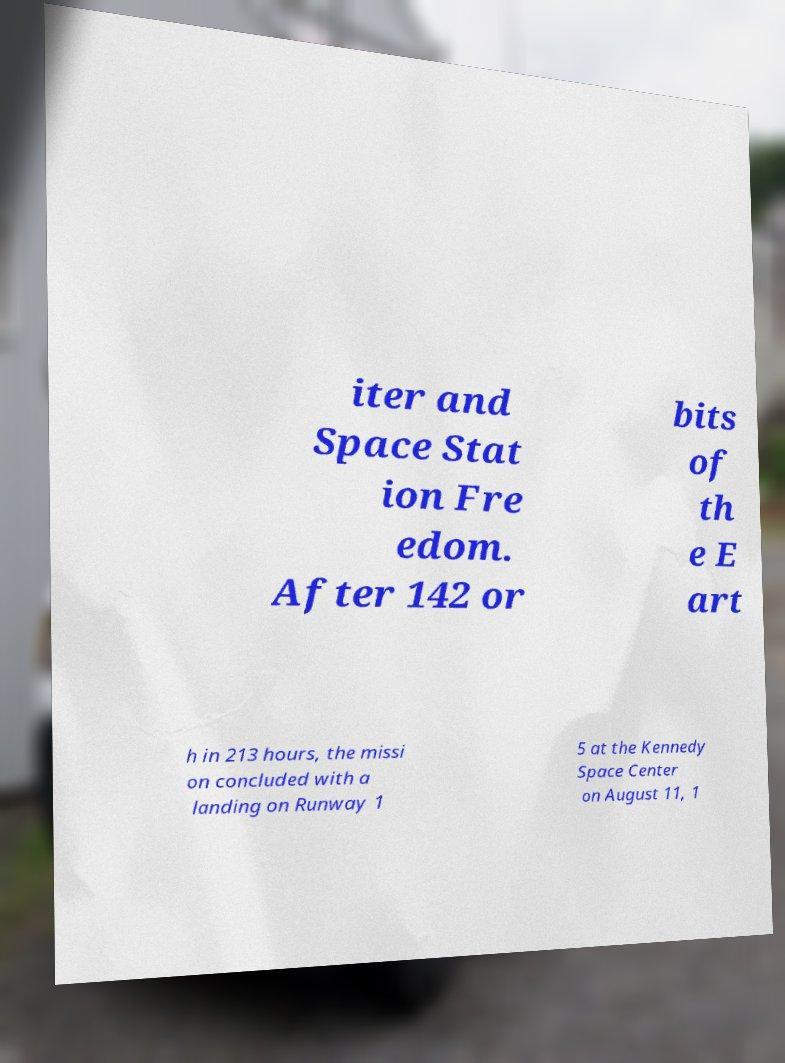Can you accurately transcribe the text from the provided image for me? iter and Space Stat ion Fre edom. After 142 or bits of th e E art h in 213 hours, the missi on concluded with a landing on Runway 1 5 at the Kennedy Space Center on August 11, 1 